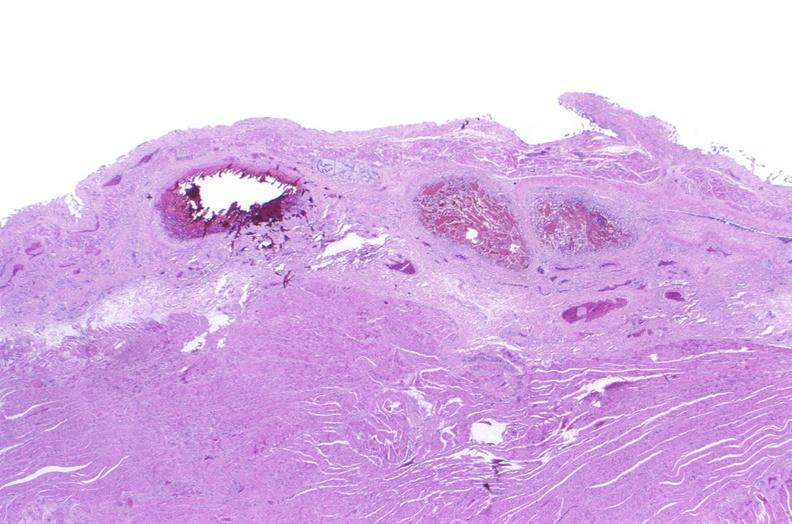s silver present?
Answer the question using a single word or phrase. No 